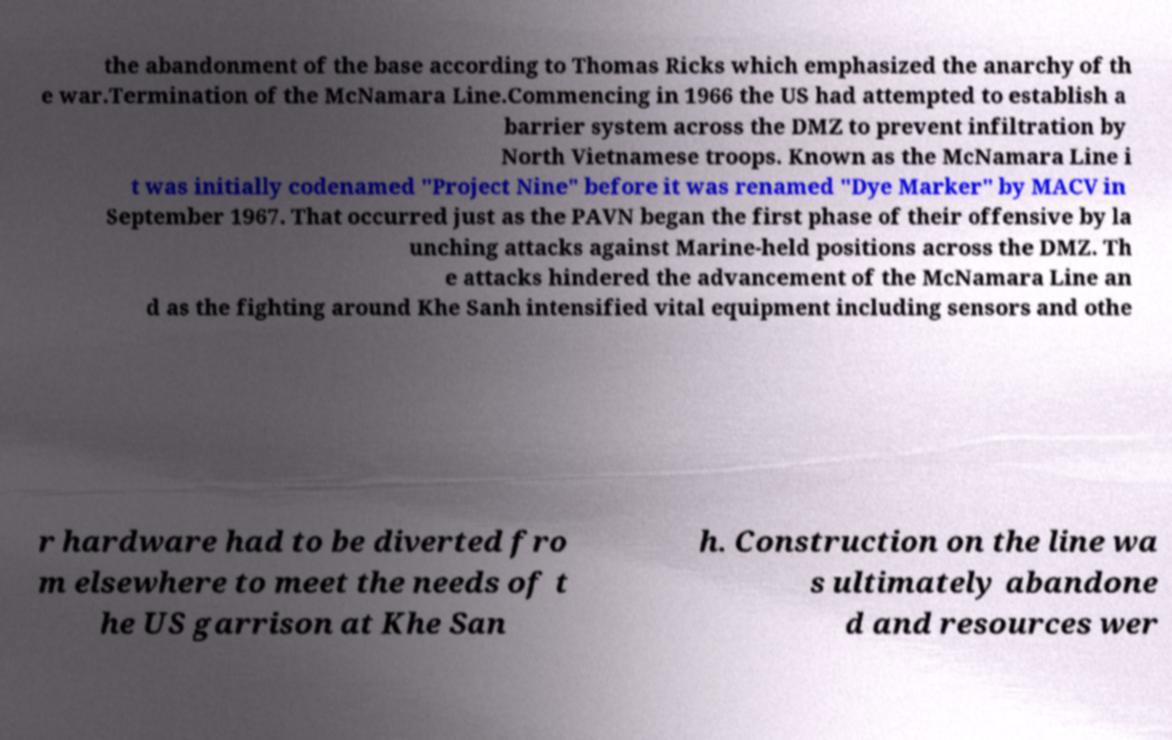Can you read and provide the text displayed in the image?This photo seems to have some interesting text. Can you extract and type it out for me? the abandonment of the base according to Thomas Ricks which emphasized the anarchy of th e war.Termination of the McNamara Line.Commencing in 1966 the US had attempted to establish a barrier system across the DMZ to prevent infiltration by North Vietnamese troops. Known as the McNamara Line i t was initially codenamed "Project Nine" before it was renamed "Dye Marker" by MACV in September 1967. That occurred just as the PAVN began the first phase of their offensive by la unching attacks against Marine-held positions across the DMZ. Th e attacks hindered the advancement of the McNamara Line an d as the fighting around Khe Sanh intensified vital equipment including sensors and othe r hardware had to be diverted fro m elsewhere to meet the needs of t he US garrison at Khe San h. Construction on the line wa s ultimately abandone d and resources wer 